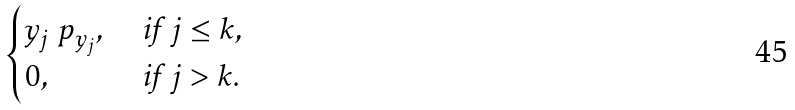Convert formula to latex. <formula><loc_0><loc_0><loc_500><loc_500>\begin{cases} y _ { j } \ p _ { y _ { j } } , & \text { if } j \leq k , \\ 0 , & \text { if } j > k . \end{cases}</formula> 